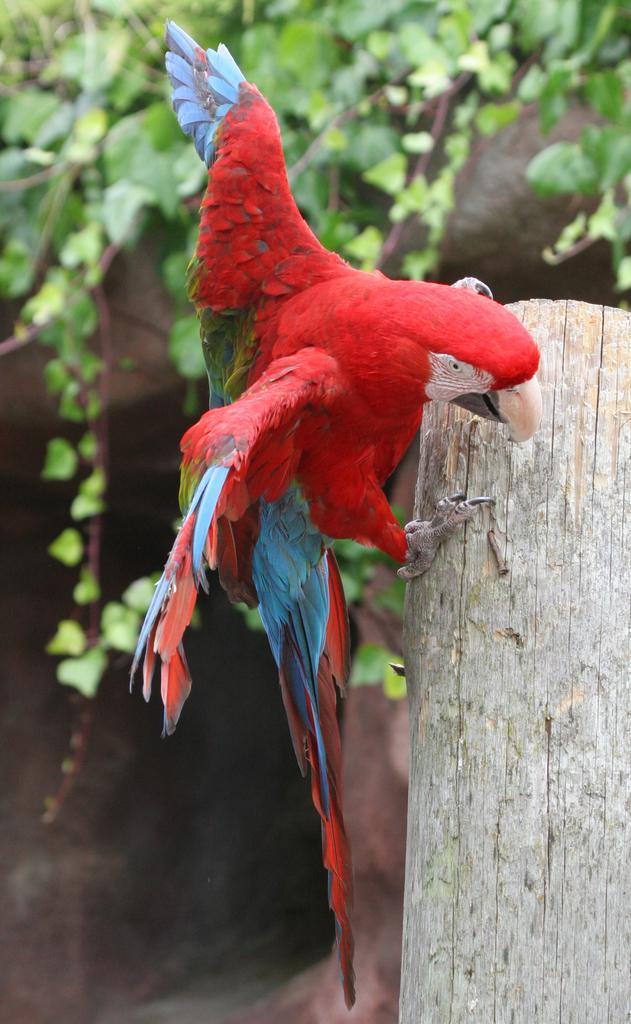Describe this image in one or two sentences. In the image in the center we can see one wood. on the wood,there is a macaw,which is in green,red and blue color. In the background we can see trees. 